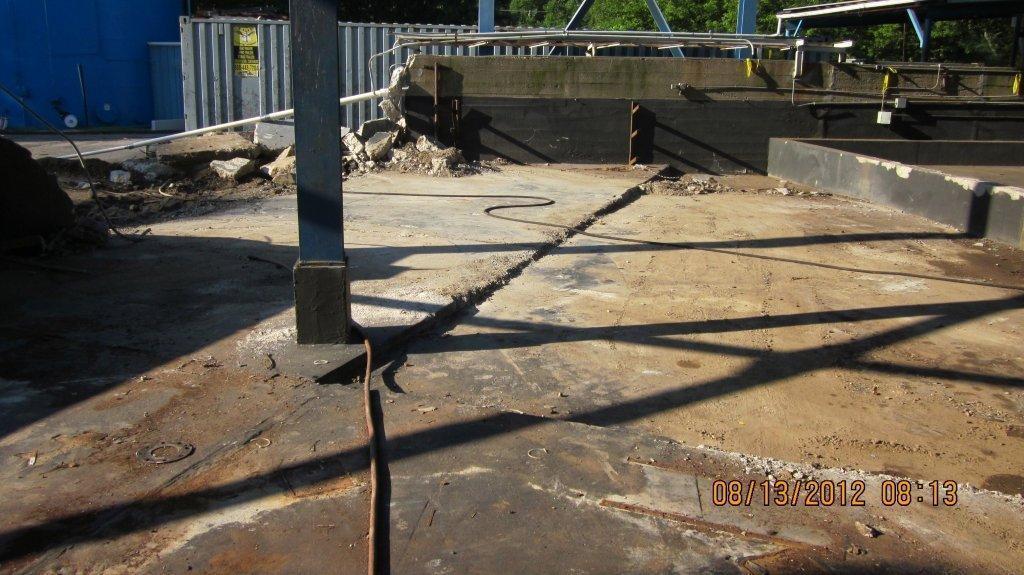Describe this image in one or two sentences. In this image there is an iron pole in the middle. In the background there is a wall. Beside the wall there are some broken stones. On the ground there is a pipe. Behind the wall there are trees and pillars. On the left side there is soil on the ground behind the stones. 